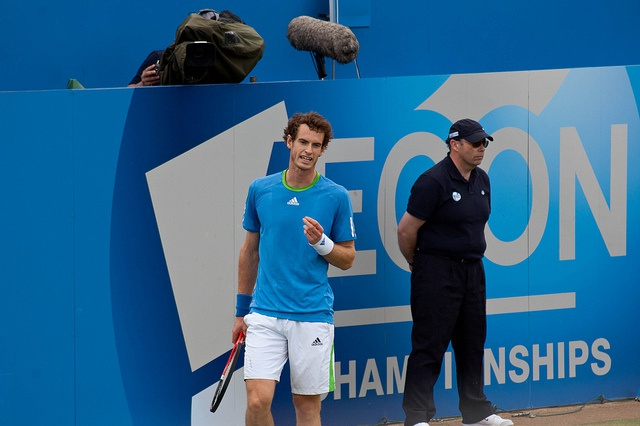Describe the objects in this image and their specific colors. I can see people in blue, teal, lavender, gray, and brown tones, people in blue, black, darkgray, and brown tones, people in blue, black, gray, and navy tones, backpack in blue, black, and gray tones, and tennis racket in blue, darkgray, black, navy, and gray tones in this image. 